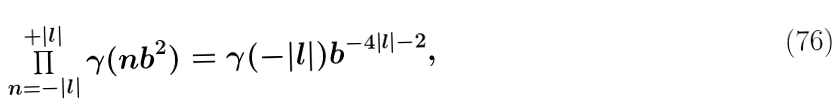Convert formula to latex. <formula><loc_0><loc_0><loc_500><loc_500>\prod _ { n = - | l | } ^ { + | l | } \gamma ( n b ^ { 2 } ) = \gamma ( - | l | ) b ^ { - 4 | l | - 2 } ,</formula> 